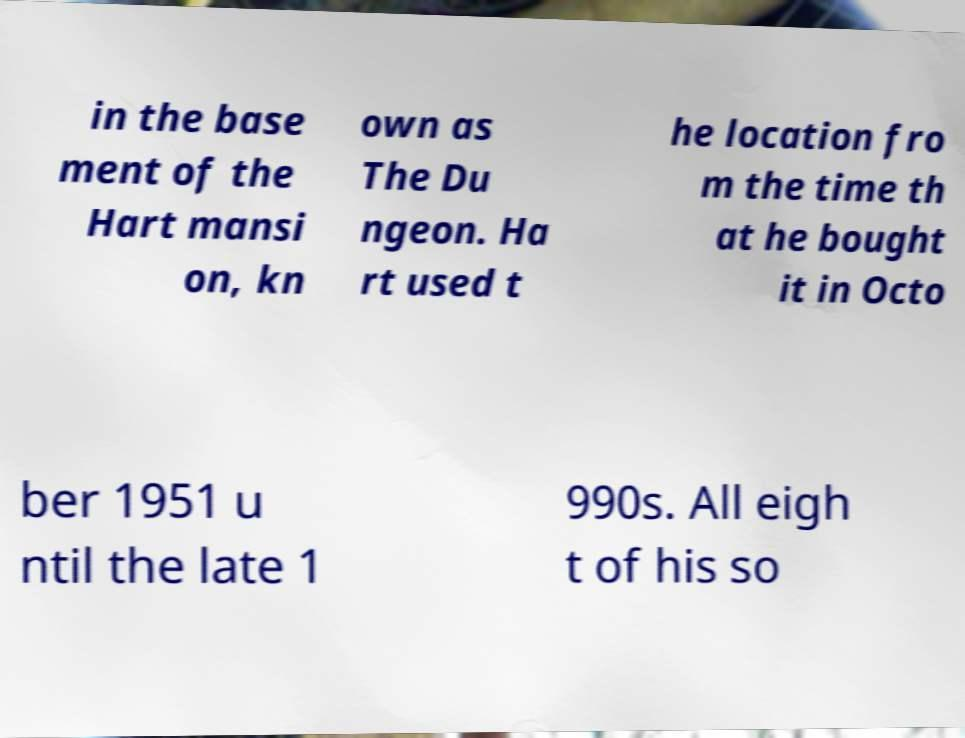Can you accurately transcribe the text from the provided image for me? in the base ment of the Hart mansi on, kn own as The Du ngeon. Ha rt used t he location fro m the time th at he bought it in Octo ber 1951 u ntil the late 1 990s. All eigh t of his so 